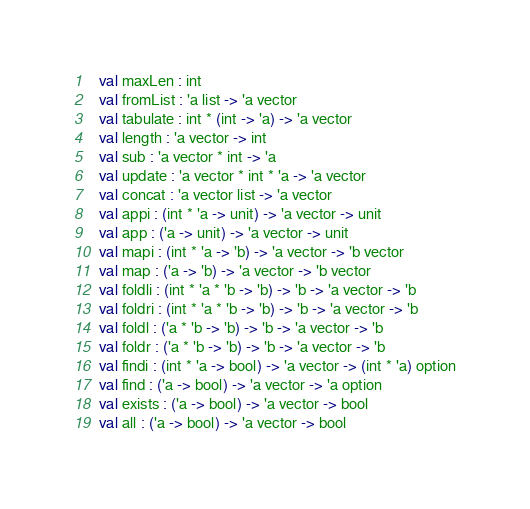<code> <loc_0><loc_0><loc_500><loc_500><_SML_>  val maxLen : int
  val fromList : 'a list -> 'a vector
  val tabulate : int * (int -> 'a) -> 'a vector
  val length : 'a vector -> int
  val sub : 'a vector * int -> 'a
  val update : 'a vector * int * 'a -> 'a vector
  val concat : 'a vector list -> 'a vector
  val appi : (int * 'a -> unit) -> 'a vector -> unit
  val app : ('a -> unit) -> 'a vector -> unit
  val mapi : (int * 'a -> 'b) -> 'a vector -> 'b vector
  val map : ('a -> 'b) -> 'a vector -> 'b vector
  val foldli : (int * 'a * 'b -> 'b) -> 'b -> 'a vector -> 'b
  val foldri : (int * 'a * 'b -> 'b) -> 'b -> 'a vector -> 'b
  val foldl : ('a * 'b -> 'b) -> 'b -> 'a vector -> 'b
  val foldr : ('a * 'b -> 'b) -> 'b -> 'a vector -> 'b
  val findi : (int * 'a -> bool) -> 'a vector -> (int * 'a) option
  val find : ('a -> bool) -> 'a vector -> 'a option
  val exists : ('a -> bool) -> 'a vector -> bool
  val all : ('a -> bool) -> 'a vector -> bool</code> 